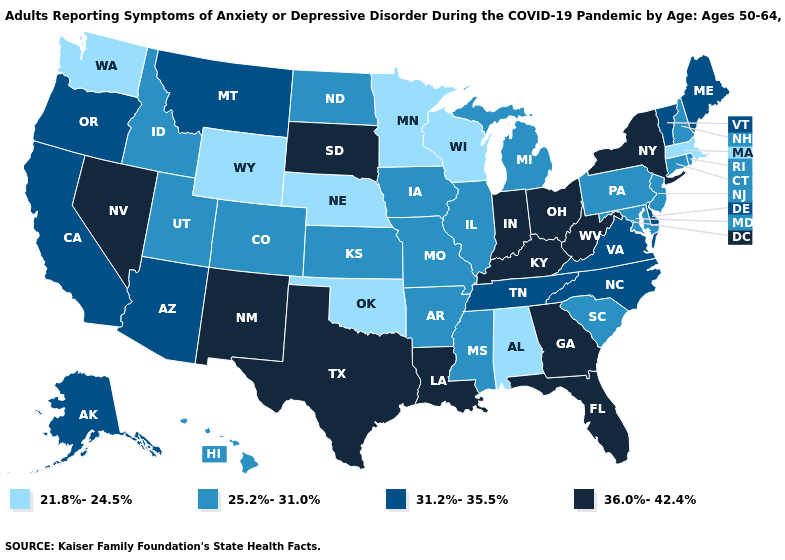Among the states that border Tennessee , does Arkansas have the lowest value?
Quick response, please. No. Name the states that have a value in the range 25.2%-31.0%?
Quick response, please. Arkansas, Colorado, Connecticut, Hawaii, Idaho, Illinois, Iowa, Kansas, Maryland, Michigan, Mississippi, Missouri, New Hampshire, New Jersey, North Dakota, Pennsylvania, Rhode Island, South Carolina, Utah. Does Alaska have the lowest value in the West?
Keep it brief. No. Name the states that have a value in the range 25.2%-31.0%?
Write a very short answer. Arkansas, Colorado, Connecticut, Hawaii, Idaho, Illinois, Iowa, Kansas, Maryland, Michigan, Mississippi, Missouri, New Hampshire, New Jersey, North Dakota, Pennsylvania, Rhode Island, South Carolina, Utah. Name the states that have a value in the range 25.2%-31.0%?
Be succinct. Arkansas, Colorado, Connecticut, Hawaii, Idaho, Illinois, Iowa, Kansas, Maryland, Michigan, Mississippi, Missouri, New Hampshire, New Jersey, North Dakota, Pennsylvania, Rhode Island, South Carolina, Utah. Among the states that border Arizona , does California have the highest value?
Be succinct. No. Does North Carolina have the same value as Tennessee?
Concise answer only. Yes. Among the states that border North Dakota , which have the highest value?
Give a very brief answer. South Dakota. Which states hav the highest value in the MidWest?
Keep it brief. Indiana, Ohio, South Dakota. What is the highest value in states that border Texas?
Concise answer only. 36.0%-42.4%. Name the states that have a value in the range 25.2%-31.0%?
Short answer required. Arkansas, Colorado, Connecticut, Hawaii, Idaho, Illinois, Iowa, Kansas, Maryland, Michigan, Mississippi, Missouri, New Hampshire, New Jersey, North Dakota, Pennsylvania, Rhode Island, South Carolina, Utah. What is the value of Rhode Island?
Answer briefly. 25.2%-31.0%. Does Idaho have a higher value than Oklahoma?
Keep it brief. Yes. How many symbols are there in the legend?
Quick response, please. 4. What is the lowest value in the USA?
Answer briefly. 21.8%-24.5%. 